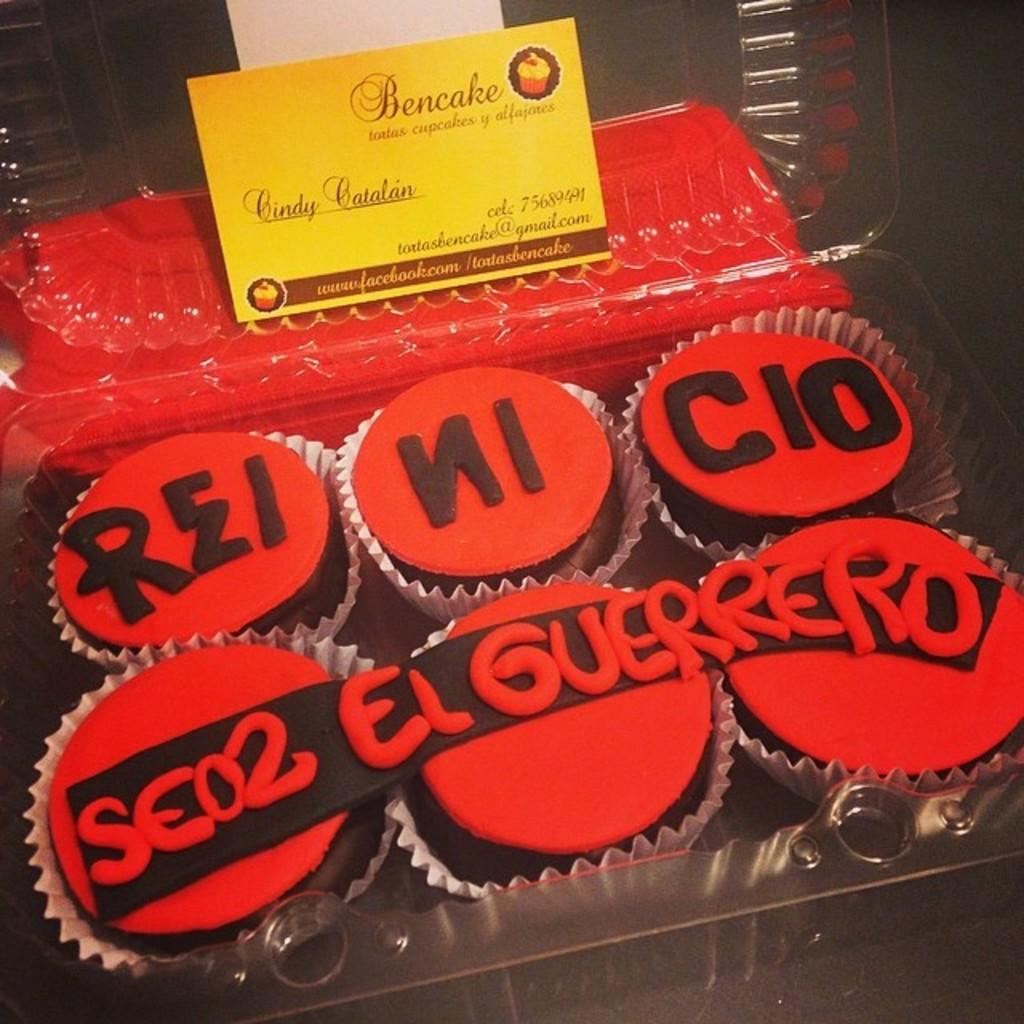What type of dessert can be seen in the image? There are cupcakes in the image. What else is present in the image besides the cupcakes? There is a card in the image. Where is the card located? The card is in a box. What time is displayed on the clock in the image? There is no clock present in the image; it only features cupcakes and a card in a box. 